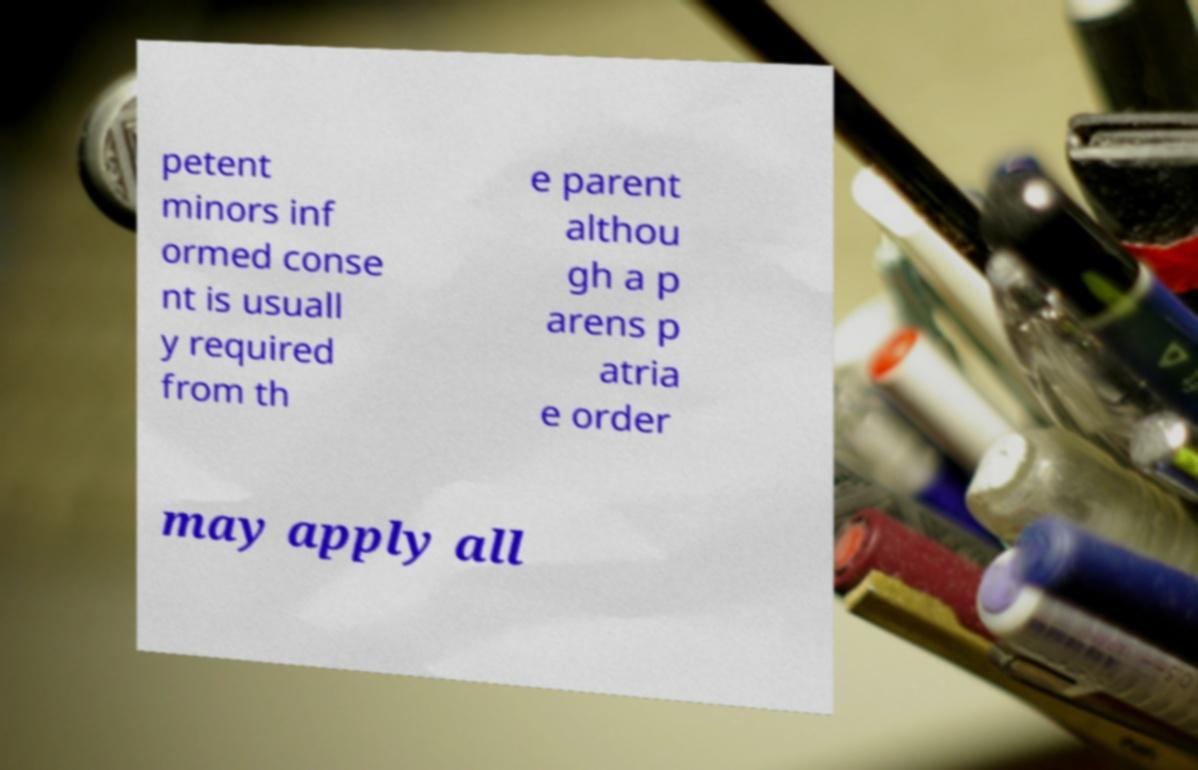Could you assist in decoding the text presented in this image and type it out clearly? petent minors inf ormed conse nt is usuall y required from th e parent althou gh a p arens p atria e order may apply all 